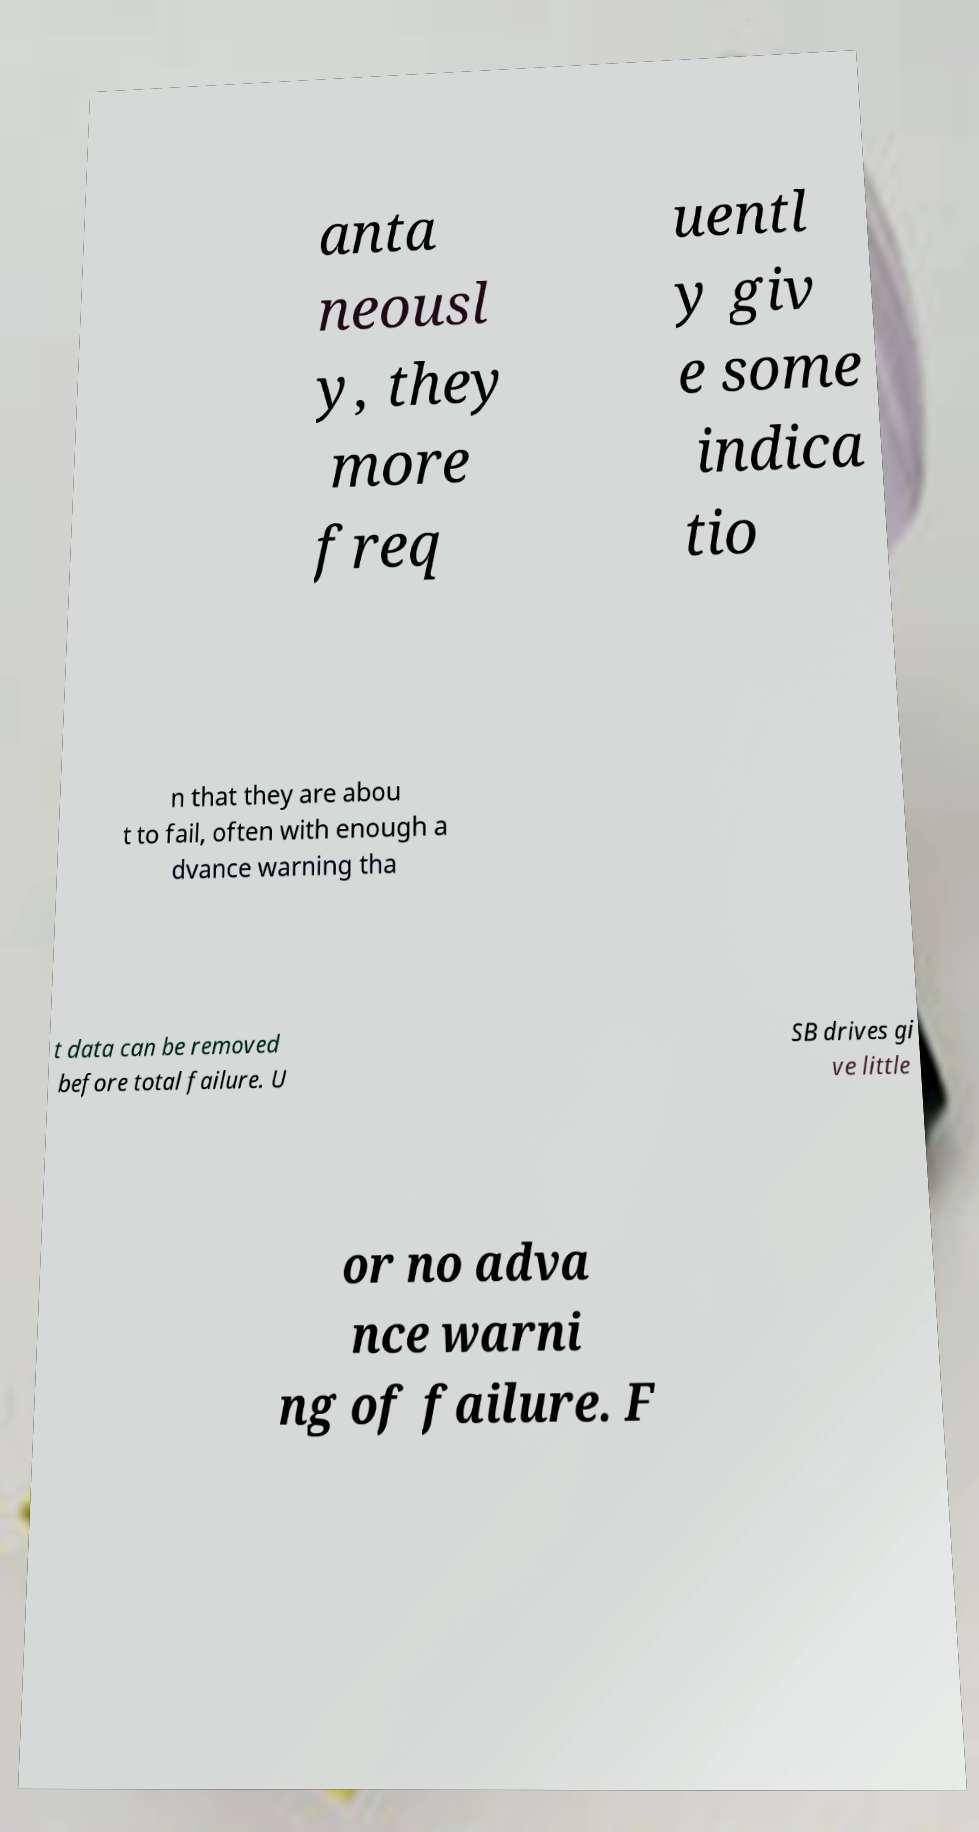What messages or text are displayed in this image? I need them in a readable, typed format. anta neousl y, they more freq uentl y giv e some indica tio n that they are abou t to fail, often with enough a dvance warning tha t data can be removed before total failure. U SB drives gi ve little or no adva nce warni ng of failure. F 